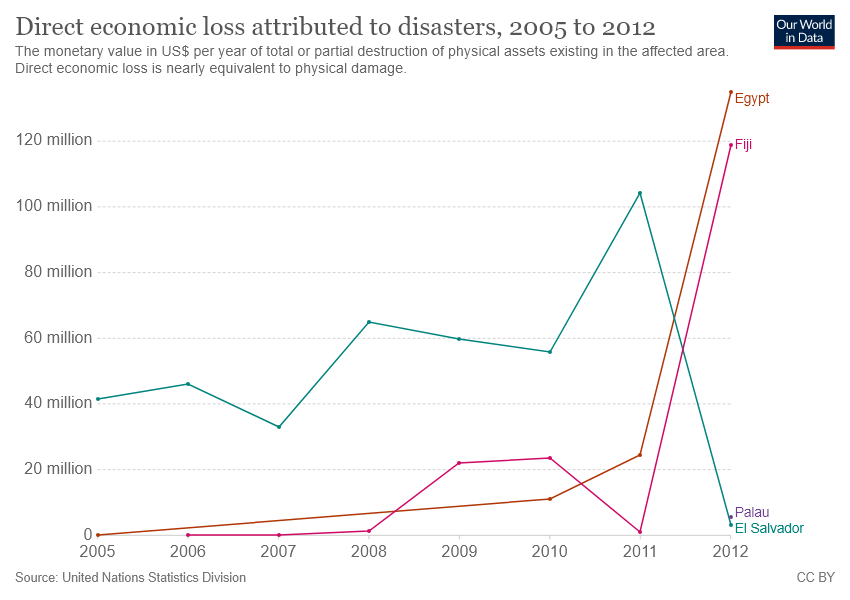List a handful of essential elements in this visual. The gap between Egypt and Fiji became the largest in 2011. Four countries are represented in the chart. 